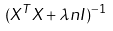Convert formula to latex. <formula><loc_0><loc_0><loc_500><loc_500>( X ^ { T } X + \lambda n I ) ^ { - 1 }</formula> 